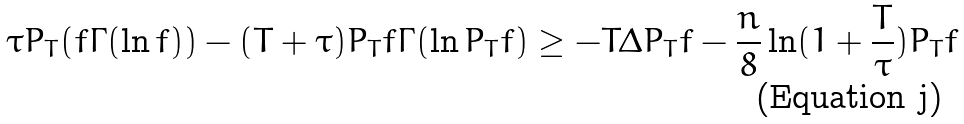Convert formula to latex. <formula><loc_0><loc_0><loc_500><loc_500>\tau P _ { T } ( f \Gamma ( \ln f ) ) - ( T + \tau ) P _ { T } f \Gamma ( \ln P _ { T } f ) \geq - T \Delta P _ { T } f - \frac { n } { 8 } \ln ( 1 + \frac { T } { \tau } ) P _ { T } f</formula> 